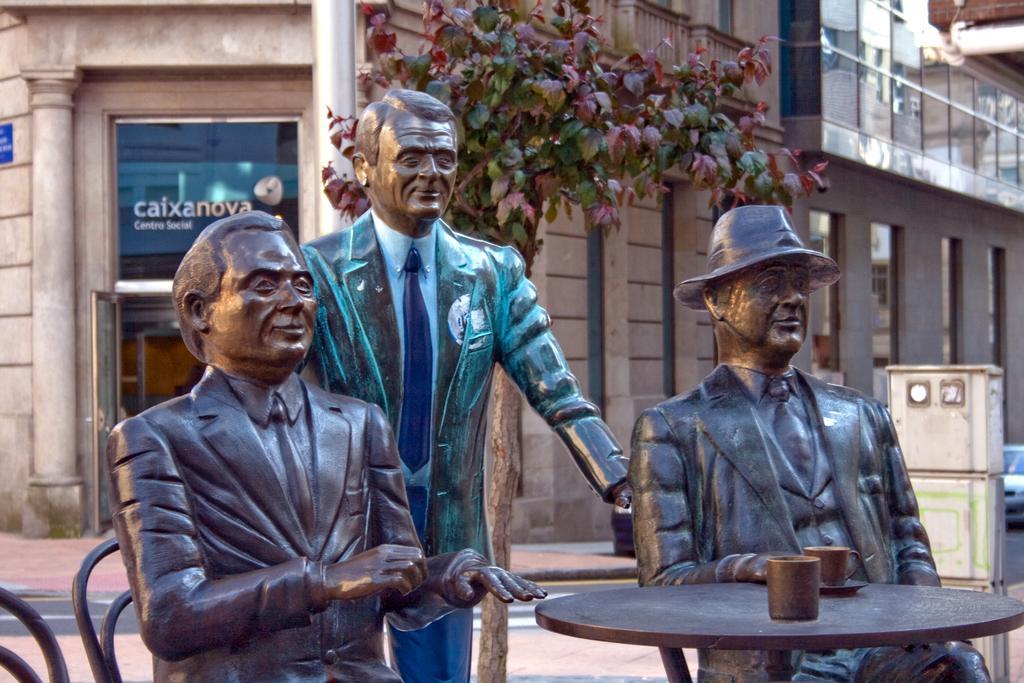How would you summarize this image in a sentence or two? There are three statues in this picture. Two of the statues were placed in the chairs in front a table. One of the statue is in standing posture. In the background there are some trees and a buildings here. 